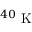Convert formula to latex. <formula><loc_0><loc_0><loc_500><loc_500>{ } ^ { 4 0 } K</formula> 